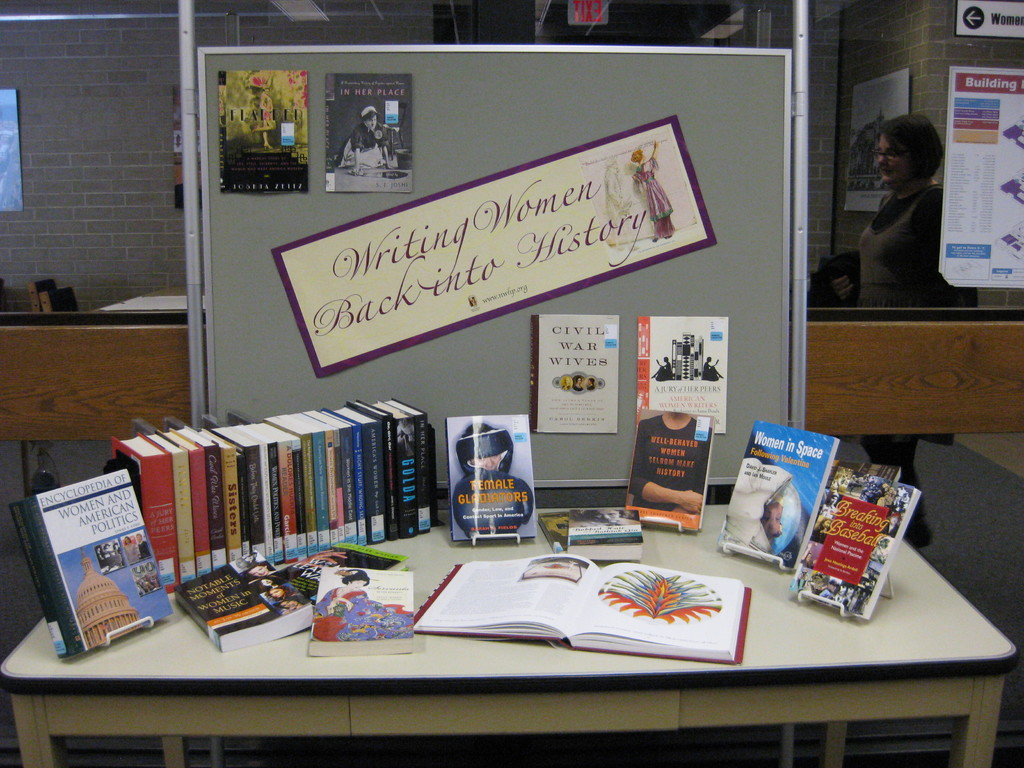Provide a one-sentence caption for the provided image.
Reference OCR token: G, Women, INNERPLACE, Building, History, Buck-inta, Writinglemen, Writing, CIVIL, WIVES, ELL-RENAT, M, Women.inSpace, LOHE, NISTORY A display of books is arranged under a banner about women in history. 